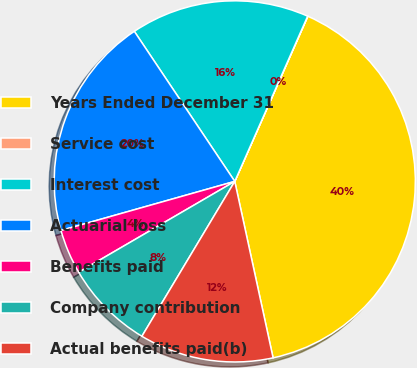Convert chart. <chart><loc_0><loc_0><loc_500><loc_500><pie_chart><fcel>Years Ended December 31<fcel>Service cost<fcel>Interest cost<fcel>Actuarial loss<fcel>Benefits paid<fcel>Company contribution<fcel>Actual benefits paid(b)<nl><fcel>39.96%<fcel>0.02%<fcel>16.0%<fcel>19.99%<fcel>4.01%<fcel>8.01%<fcel>12.0%<nl></chart> 